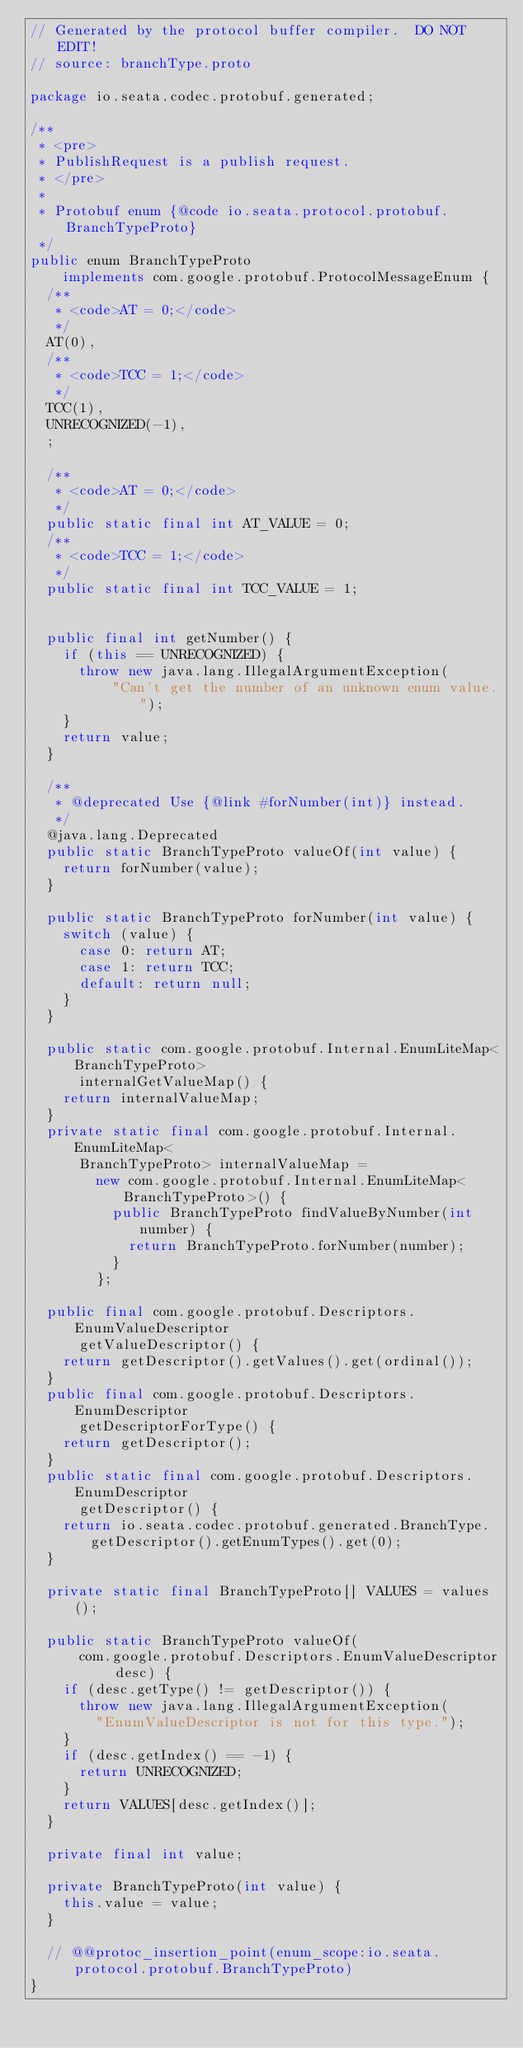Convert code to text. <code><loc_0><loc_0><loc_500><loc_500><_Java_>// Generated by the protocol buffer compiler.  DO NOT EDIT!
// source: branchType.proto

package io.seata.codec.protobuf.generated;

/**
 * <pre>
 * PublishRequest is a publish request.
 * </pre>
 *
 * Protobuf enum {@code io.seata.protocol.protobuf.BranchTypeProto}
 */
public enum BranchTypeProto
    implements com.google.protobuf.ProtocolMessageEnum {
  /**
   * <code>AT = 0;</code>
   */
  AT(0),
  /**
   * <code>TCC = 1;</code>
   */
  TCC(1),
  UNRECOGNIZED(-1),
  ;

  /**
   * <code>AT = 0;</code>
   */
  public static final int AT_VALUE = 0;
  /**
   * <code>TCC = 1;</code>
   */
  public static final int TCC_VALUE = 1;


  public final int getNumber() {
    if (this == UNRECOGNIZED) {
      throw new java.lang.IllegalArgumentException(
          "Can't get the number of an unknown enum value.");
    }
    return value;
  }

  /**
   * @deprecated Use {@link #forNumber(int)} instead.
   */
  @java.lang.Deprecated
  public static BranchTypeProto valueOf(int value) {
    return forNumber(value);
  }

  public static BranchTypeProto forNumber(int value) {
    switch (value) {
      case 0: return AT;
      case 1: return TCC;
      default: return null;
    }
  }

  public static com.google.protobuf.Internal.EnumLiteMap<BranchTypeProto>
      internalGetValueMap() {
    return internalValueMap;
  }
  private static final com.google.protobuf.Internal.EnumLiteMap<
      BranchTypeProto> internalValueMap =
        new com.google.protobuf.Internal.EnumLiteMap<BranchTypeProto>() {
          public BranchTypeProto findValueByNumber(int number) {
            return BranchTypeProto.forNumber(number);
          }
        };

  public final com.google.protobuf.Descriptors.EnumValueDescriptor
      getValueDescriptor() {
    return getDescriptor().getValues().get(ordinal());
  }
  public final com.google.protobuf.Descriptors.EnumDescriptor
      getDescriptorForType() {
    return getDescriptor();
  }
  public static final com.google.protobuf.Descriptors.EnumDescriptor
      getDescriptor() {
    return io.seata.codec.protobuf.generated.BranchType.getDescriptor().getEnumTypes().get(0);
  }

  private static final BranchTypeProto[] VALUES = values();

  public static BranchTypeProto valueOf(
      com.google.protobuf.Descriptors.EnumValueDescriptor desc) {
    if (desc.getType() != getDescriptor()) {
      throw new java.lang.IllegalArgumentException(
        "EnumValueDescriptor is not for this type.");
    }
    if (desc.getIndex() == -1) {
      return UNRECOGNIZED;
    }
    return VALUES[desc.getIndex()];
  }

  private final int value;

  private BranchTypeProto(int value) {
    this.value = value;
  }

  // @@protoc_insertion_point(enum_scope:io.seata.protocol.protobuf.BranchTypeProto)
}

</code> 